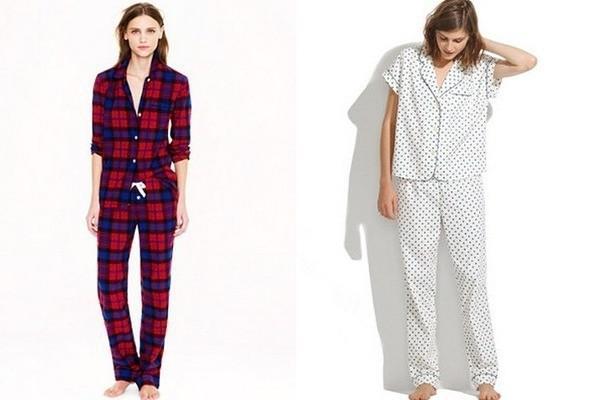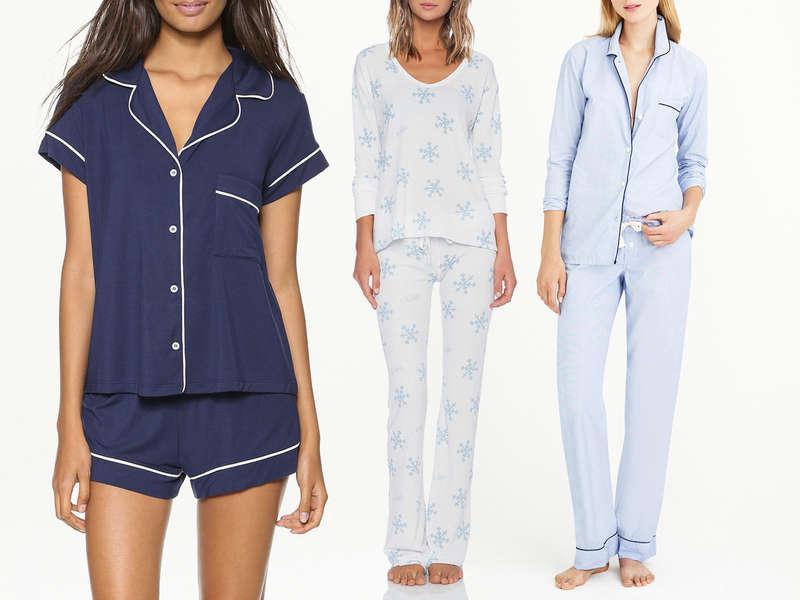The first image is the image on the left, the second image is the image on the right. Assess this claim about the two images: "there are models with legs showing". Correct or not? Answer yes or no. Yes. The first image is the image on the left, the second image is the image on the right. Assess this claim about the two images: "An image shows three models side-by-side, all wearing long-legged loungewear.". Correct or not? Answer yes or no. No. 